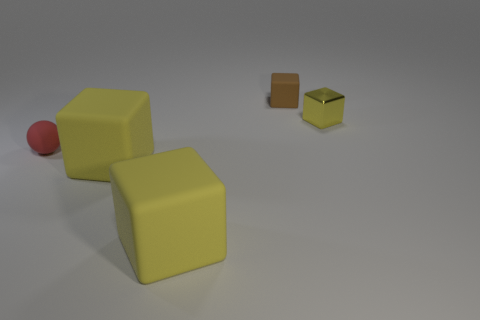How many yellow blocks must be subtracted to get 1 yellow blocks? 2 Add 4 rubber balls. How many objects exist? 9 Subtract all yellow metallic cubes. How many cubes are left? 3 Subtract all spheres. How many objects are left? 4 Subtract 1 spheres. How many spheres are left? 0 Subtract all brown blocks. How many blocks are left? 3 Subtract all rubber things. Subtract all tiny brown rubber things. How many objects are left? 0 Add 3 brown blocks. How many brown blocks are left? 4 Add 1 yellow shiny objects. How many yellow shiny objects exist? 2 Subtract 0 cyan cylinders. How many objects are left? 5 